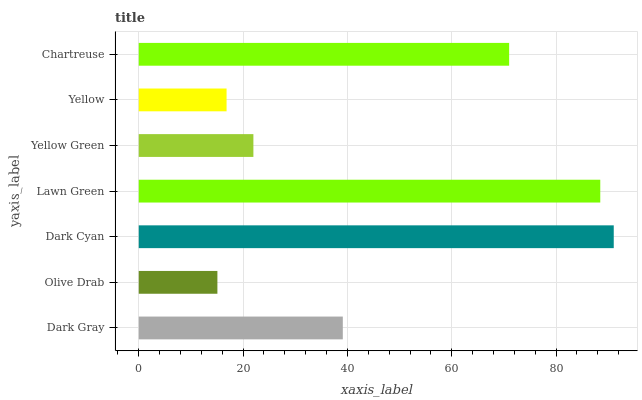Is Olive Drab the minimum?
Answer yes or no. Yes. Is Dark Cyan the maximum?
Answer yes or no. Yes. Is Dark Cyan the minimum?
Answer yes or no. No. Is Olive Drab the maximum?
Answer yes or no. No. Is Dark Cyan greater than Olive Drab?
Answer yes or no. Yes. Is Olive Drab less than Dark Cyan?
Answer yes or no. Yes. Is Olive Drab greater than Dark Cyan?
Answer yes or no. No. Is Dark Cyan less than Olive Drab?
Answer yes or no. No. Is Dark Gray the high median?
Answer yes or no. Yes. Is Dark Gray the low median?
Answer yes or no. Yes. Is Yellow Green the high median?
Answer yes or no. No. Is Olive Drab the low median?
Answer yes or no. No. 